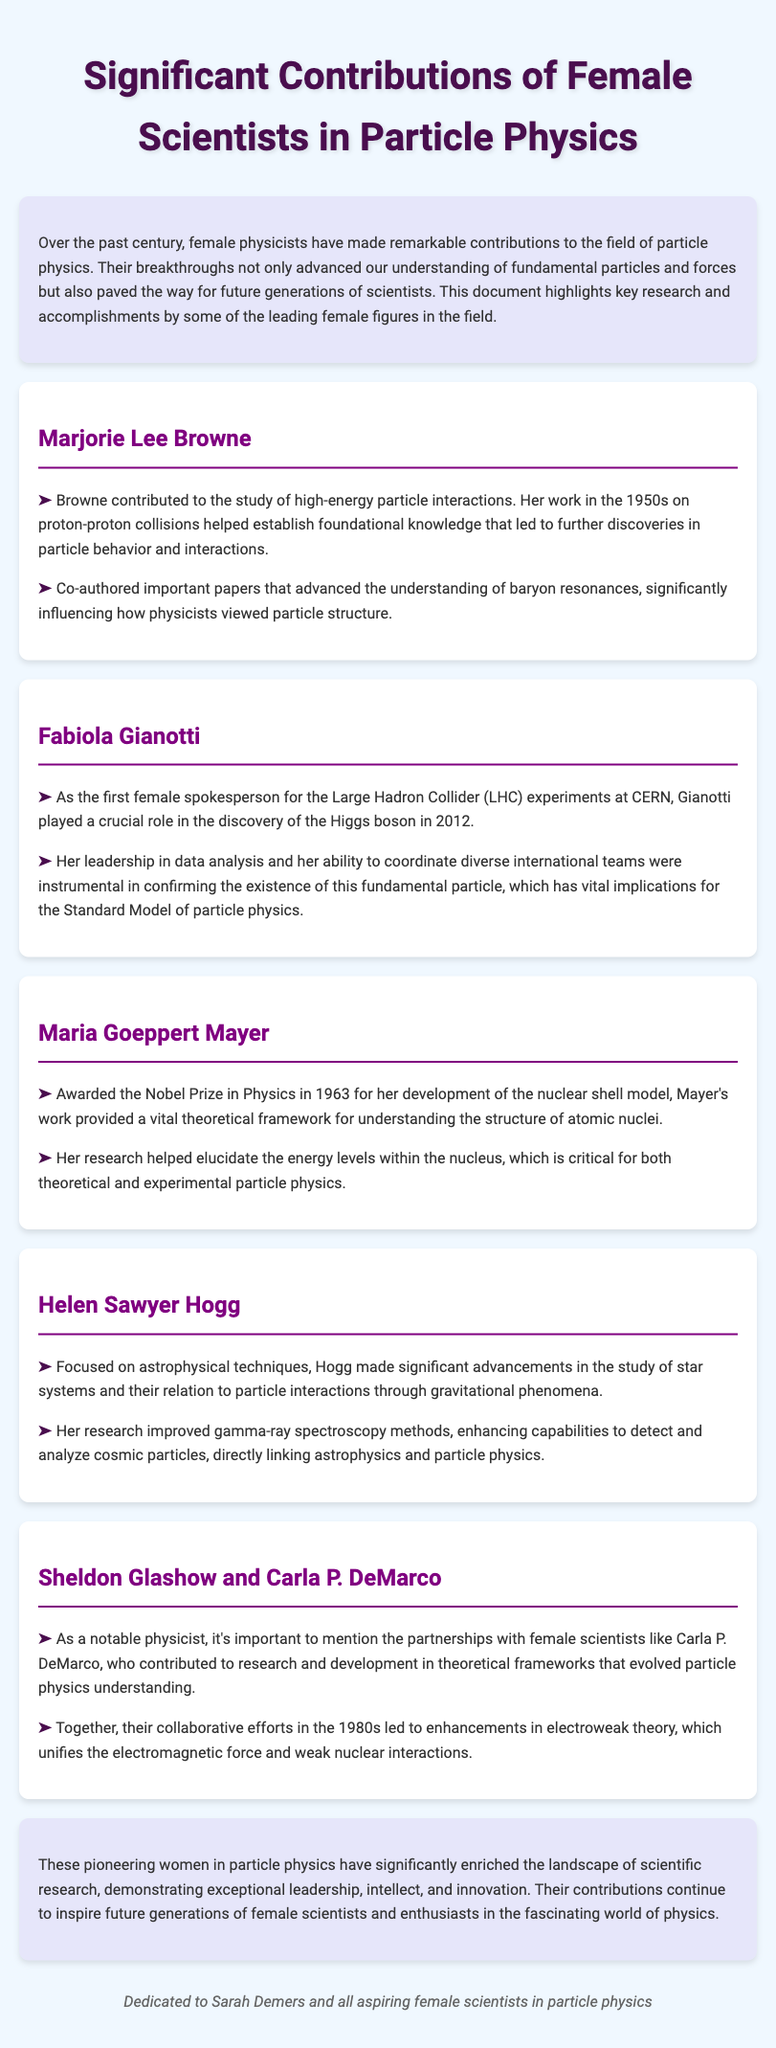What is the title of the document? The title of the document is found in the <title> tag within the head section.
Answer: Significant Contributions of Female Scientists in Particle Physics Who is recognized for the discovery of the Higgs boson? The document specifically mentions Fabiola Gianotti as the first female spokesperson for the LHC experiments and her role in the discovery of the Higgs boson.
Answer: Fabiola Gianotti In which year did Maria Goeppert Mayer receive the Nobel Prize in Physics? The document states that Mayer was awarded the Nobel Prize in Physics in 1963.
Answer: 1963 What was the main contribution of Marjorie Lee Browne? The document indicates that Browne contributed to the study of high-energy particle interactions, specifically on proton-proton collisions.
Answer: High-energy particle interactions Who collaborated with Sheldon Glashow? The document mentions Carla P. DeMarco as a notable partnership in researching theoretical frameworks in particle physics.
Answer: Carla P. DeMarco What advanced techniques did Helen Sawyer Hogg focus on? The document highlights Hogg's improvements in gamma-ray spectroscopy methods related to detecting and analyzing cosmic particles.
Answer: Gamma-ray spectroscopy Which particle does the Higgs boson have vital implications for? The document discusses the Higgs boson and its significance for the Standard Model of particle physics.
Answer: Standard Model What type of research did Helen Sawyer Hogg relate to? The document states that Hogg made advancements in understanding star systems and their relation to particle interactions.
Answer: Astrophysical techniques What is the main purpose of this document? The document introduces the significant contributions of female scientists in particle physics to inspire future generations.
Answer: Inspire future generations 